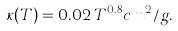<formula> <loc_0><loc_0><loc_500><loc_500>\kappa ( T ) = 0 . 0 2 \, T ^ { 0 . 8 } c m ^ { 2 } / g .</formula> 